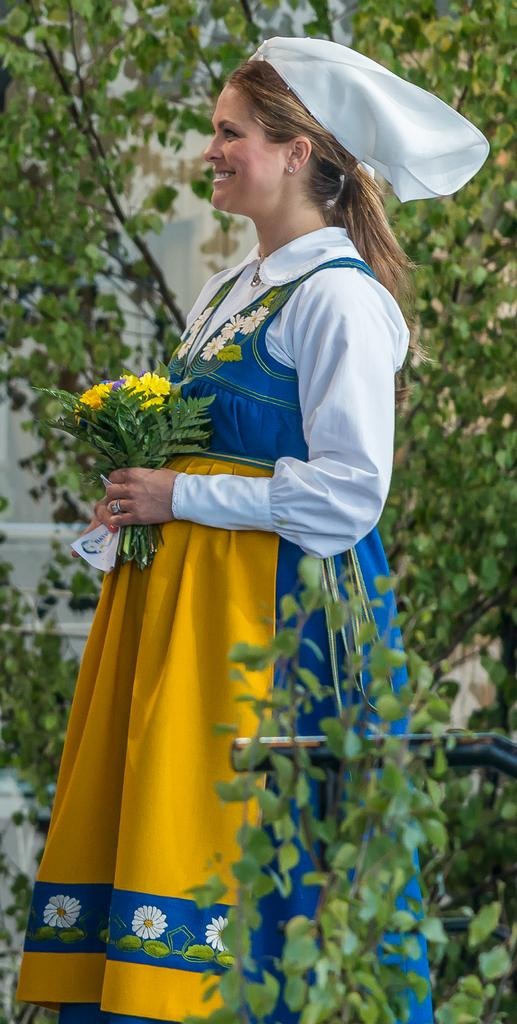What is the woman in the image doing? The woman is standing in the image and holding flowers. What can be seen in the foreground of the image? There are plants in the foreground of the image. Where is the mailbox located in the image? There is no mailbox present in the image. What type of payment is being made in the image? There is no payment being made in the image; the woman is holding flowers. 